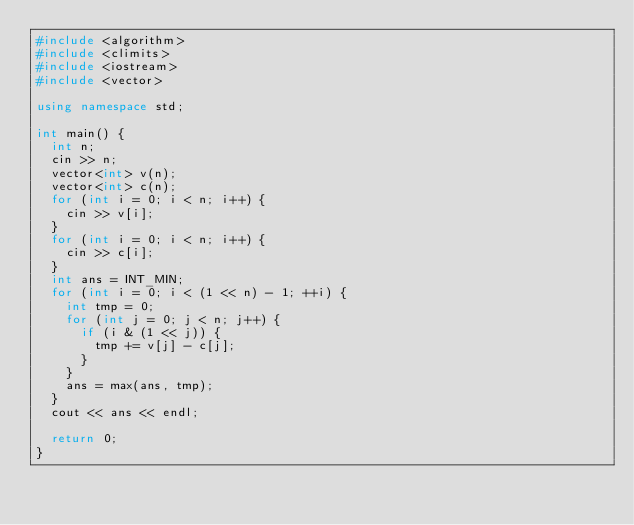Convert code to text. <code><loc_0><loc_0><loc_500><loc_500><_C++_>#include <algorithm>
#include <climits>
#include <iostream>
#include <vector>

using namespace std;

int main() {
  int n;
  cin >> n;
  vector<int> v(n);
  vector<int> c(n);
  for (int i = 0; i < n; i++) {
    cin >> v[i];
  }
  for (int i = 0; i < n; i++) {
    cin >> c[i];
  }
  int ans = INT_MIN;
  for (int i = 0; i < (1 << n) - 1; ++i) {
    int tmp = 0;
    for (int j = 0; j < n; j++) {
      if (i & (1 << j)) {
        tmp += v[j] - c[j];
      }
    }
    ans = max(ans, tmp);
  }
  cout << ans << endl;

  return 0;
}
</code> 